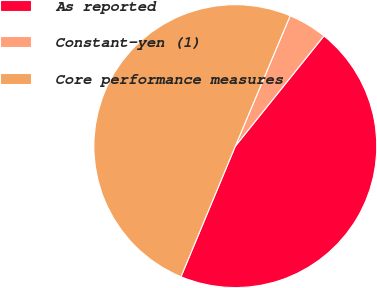Convert chart. <chart><loc_0><loc_0><loc_500><loc_500><pie_chart><fcel>As reported<fcel>Constant-yen (1)<fcel>Core performance measures<nl><fcel>45.5%<fcel>4.44%<fcel>50.06%<nl></chart> 